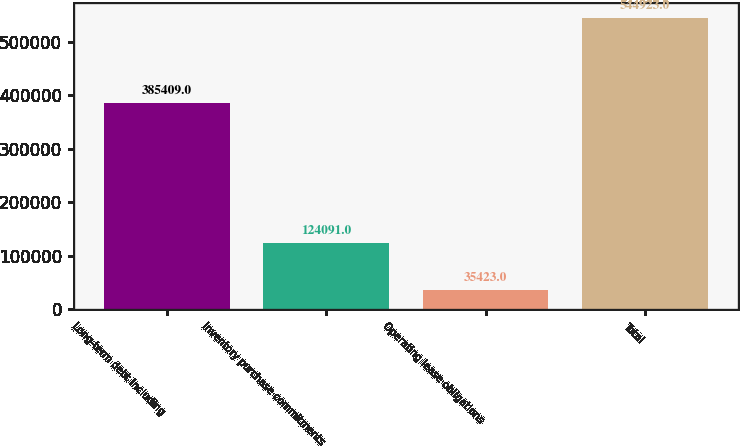Convert chart. <chart><loc_0><loc_0><loc_500><loc_500><bar_chart><fcel>Long-term debt including<fcel>Inventory purchase commitments<fcel>Operating lease obligations<fcel>Total<nl><fcel>385409<fcel>124091<fcel>35423<fcel>544923<nl></chart> 